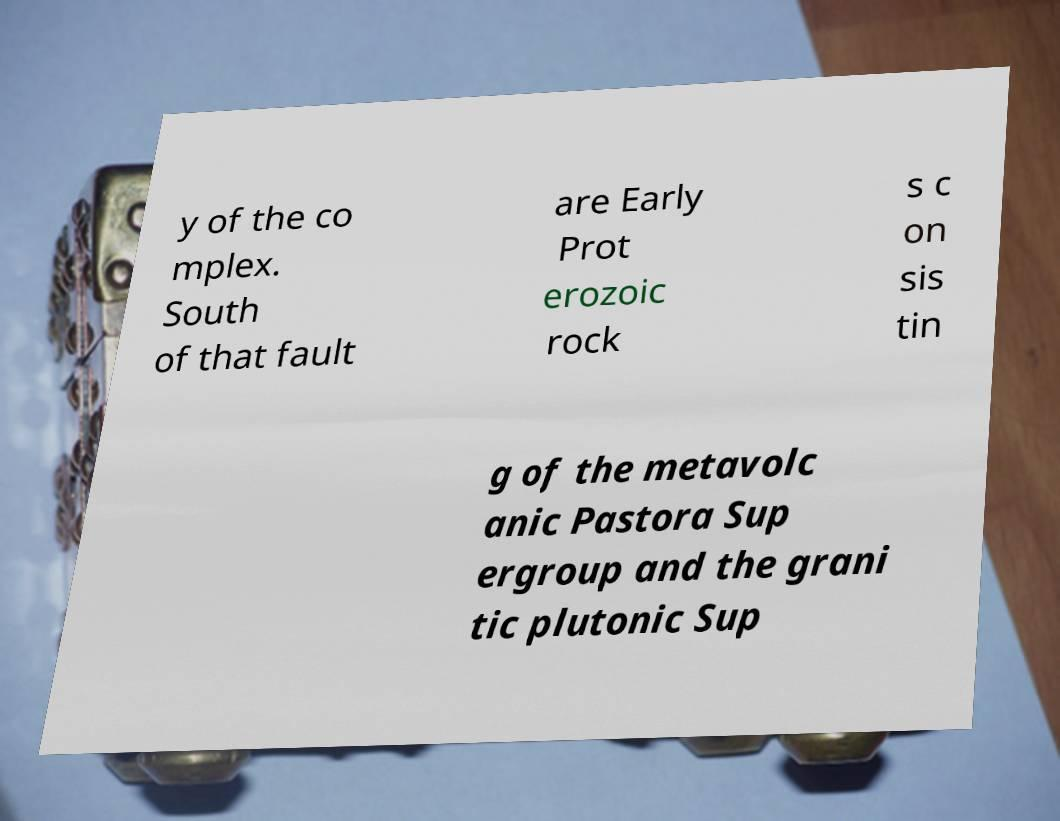Could you extract and type out the text from this image? y of the co mplex. South of that fault are Early Prot erozoic rock s c on sis tin g of the metavolc anic Pastora Sup ergroup and the grani tic plutonic Sup 